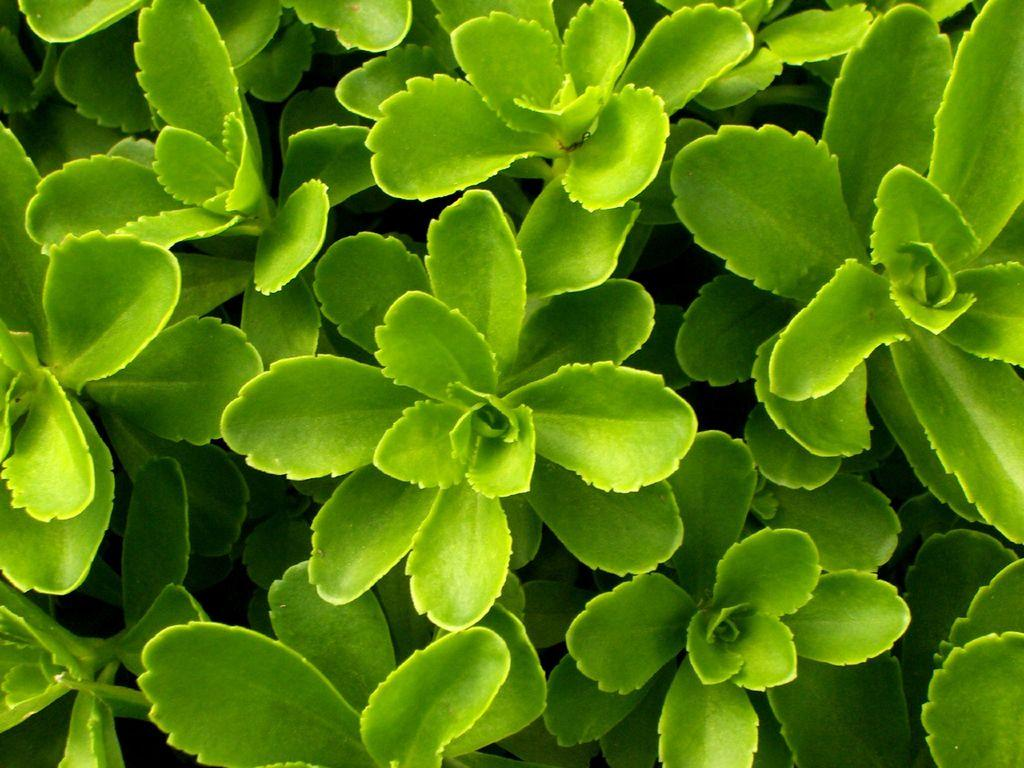What type of living organisms can be seen in the image? Plants can be seen in the image. What color are the leaves of the plants in the image? The leaves of the plants in the image are green. What type of knot is used to tie the plants together in the image? There is no knot present in the image, as the plants are not tied together. What type of wine is being served with the plants in the image? There is no wine present in the image, as the focus is on the plants and their green leaves. 